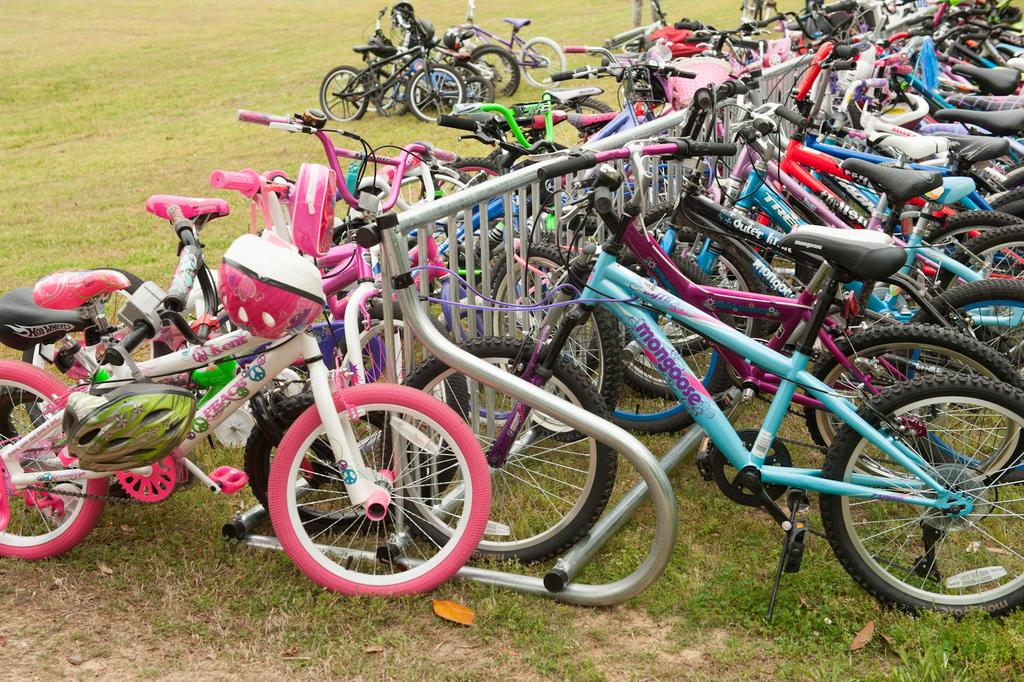What type of vehicles are present in the image? There are bicycles in the image. What is located on the ground in the image? There is a railing on the ground in the image. What safety equipment is associated with the bicycles in the image? There are helmets associated with the bicycles in the image. What type of skirt is being worn by the bicycle in the image? There are no skirts present in the image, as bicycles are vehicles and do not wear clothing. 